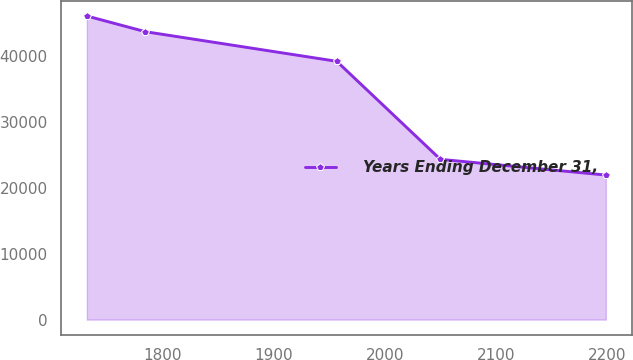Convert chart to OTSL. <chart><loc_0><loc_0><loc_500><loc_500><line_chart><ecel><fcel>Years Ending December 31,<nl><fcel>1731.51<fcel>46046.8<nl><fcel>1784.31<fcel>43662.9<nl><fcel>1956.56<fcel>39173.4<nl><fcel>2049.89<fcel>24306.9<nl><fcel>2198.91<fcel>21923<nl></chart> 